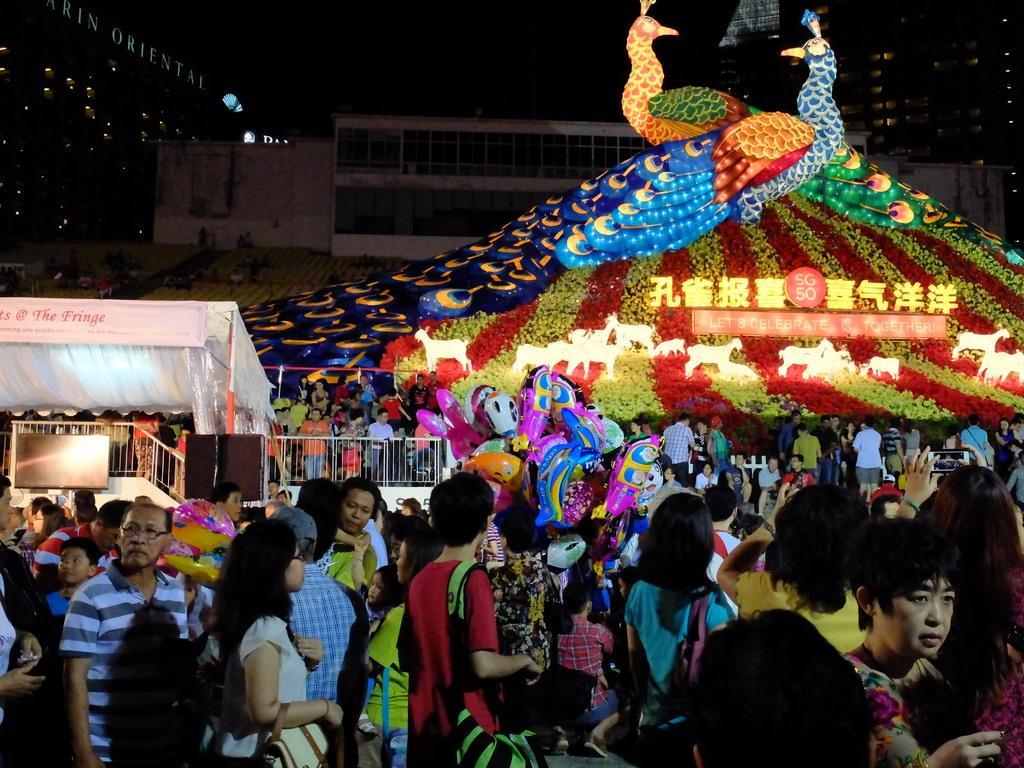In one or two sentences, can you explain what this image depicts? At the bottom of the image there are many people. Behind them on the left side there is a stage with roof, rods and railings. Beside the stage there are many toys. There are some decorative things with lights, name boards and some other things. In the background there is a building with walls and windows. And also there are few people sitting on the chairs. Behind them there are buildings with lights and also there is a name board.  